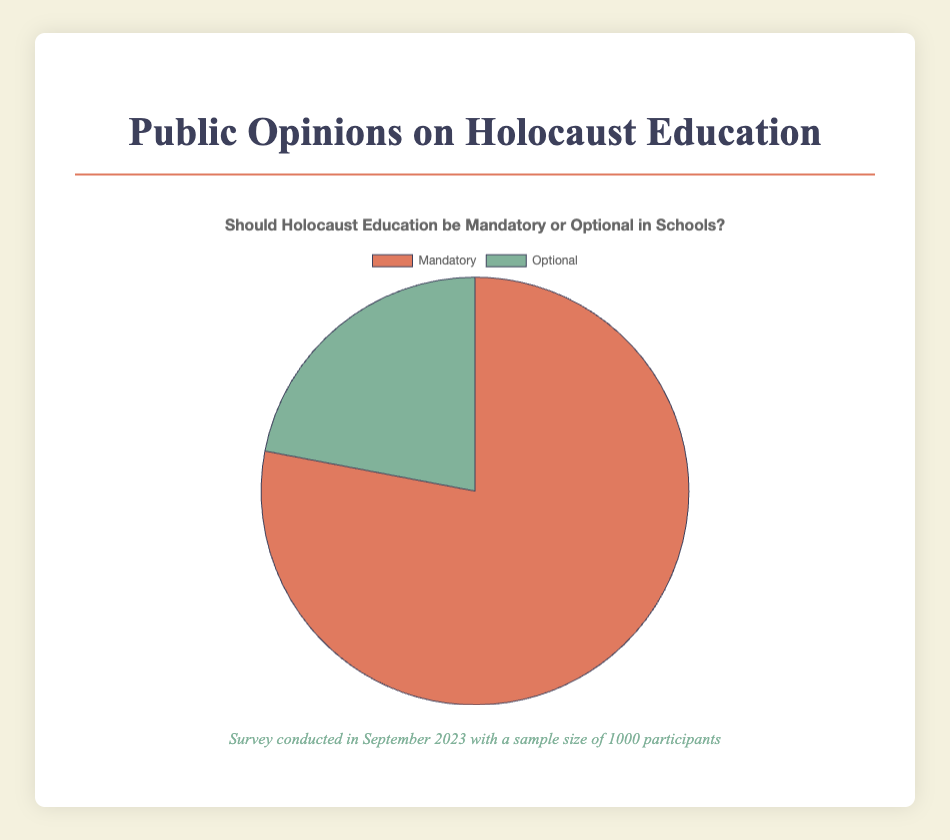What percentage of respondents believe Holocaust education should be mandatory? The figure shows a pie chart displaying two opinions: Mandatory and Optional. The segment representing Mandatory is labeled with a value of 78%.
Answer: 78% How many respondents believe Holocaust education should be optional? To find out how many respondents believe Holocaust education should be optional, we use the percentage given in the chart. The Optional segment is 22%, and the total sample size is 1000. We calculate 22% of 1000, which is 0.22 * 1000 = 220.
Answer: 220 Which opinion is in the majority based on the pie chart? The pie chart shows two opinions: Mandatory (78%) and Optional (22%). The higher percentage, 78%, represents the majority opinion of Holocaust education being mandatory.
Answer: Mandatory By what percentage does the Mandatory opinion exceed the Optional opinion? To determine how much the Mandatory opinion exceeds the Optional opinion, we subtract the percentage for Optional from the percentage for Mandatory: 78% - 22% = 56%.
Answer: 56% What does the color red represent in the pie chart? The pie chart uses colors to differentiate between the two opinions. The segment representing "Mandatory" is filled with red. Thus, red represents the opinion that Holocaust education should be mandatory.
Answer: Mandatory If five more percent of respondents believed Holocaust education should be optional, what would be the new percentage for those who think it should be mandatory? If 5% more respondents believed it should be optional, this would increase the Optional segment to 27%. Since the pie chart must total 100%, the new Mandatory percentage would be 100% - 27% = 73%.
Answer: 73% Is the proportion of people who think Holocaust education should be optional less than a quarter? A quarter, or 25%, is more than the percentage representing the Optional opinion, which is 22%. Therefore, the proportion of people who think it should be optional is indeed less than a quarter.
Answer: Yes What is the total percentage of surveyed participants represented in the pie chart? To verify that the pie chart properly accounts for all respondents, we sum the percentages for both opinions: 78% (Mandatory) + 22% (Optional) = 100%.
Answer: 100% Find the ratio of respondents who believe Holocaust education should be mandatory to those who believe it should be optional. The percentages for Mandatory and Optional are 78% and 22%, respectively. The ratio is found by dividing these percentages: 78 / 22 = 3.545 (approx. 3.55:1).
Answer: 3.55:1 